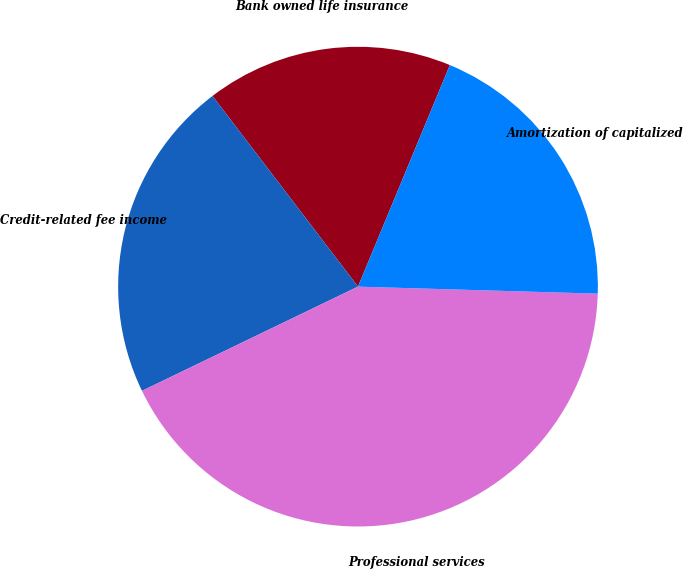Convert chart to OTSL. <chart><loc_0><loc_0><loc_500><loc_500><pie_chart><fcel>Bank owned life insurance<fcel>Credit-related fee income<fcel>Professional services<fcel>Amortization of capitalized<nl><fcel>16.63%<fcel>21.78%<fcel>42.38%<fcel>19.21%<nl></chart> 